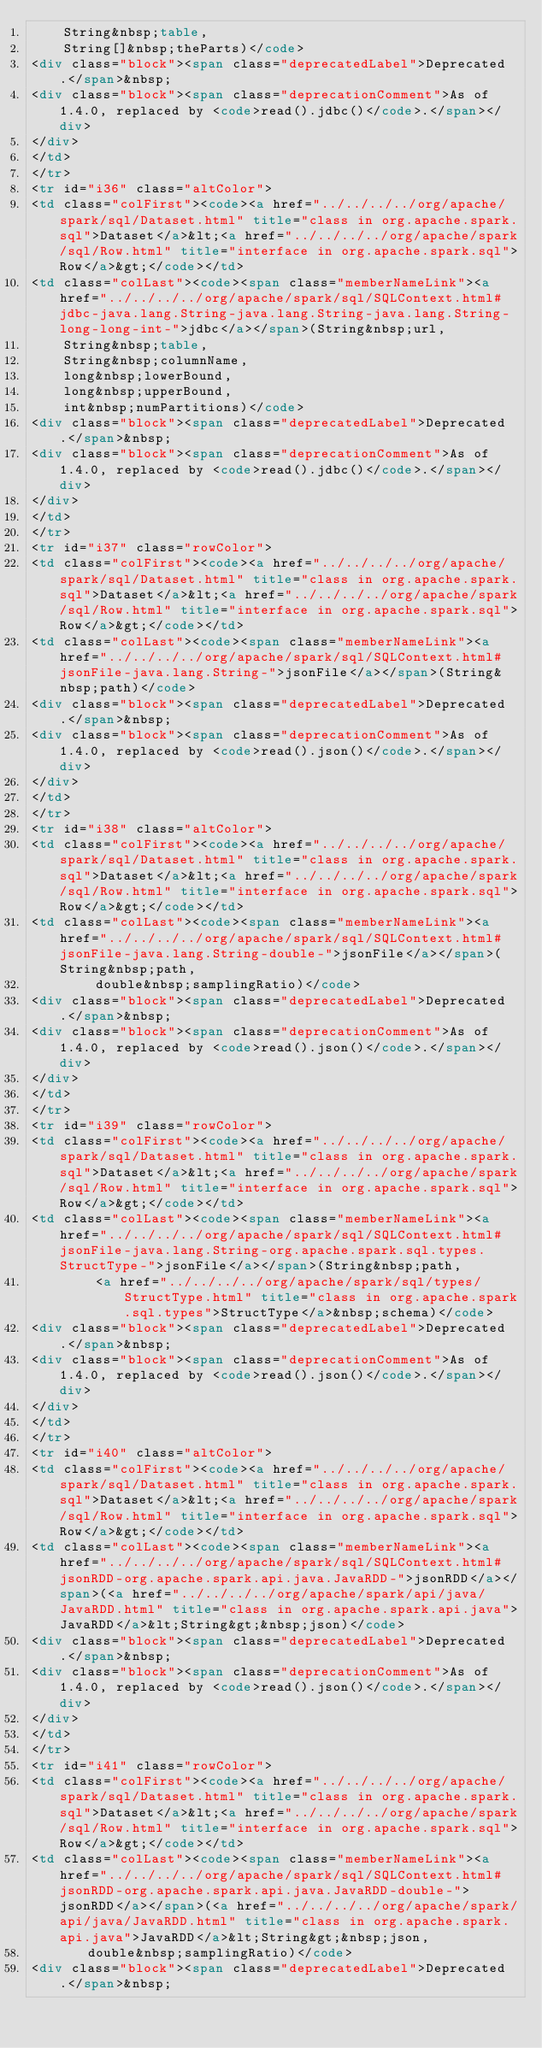<code> <loc_0><loc_0><loc_500><loc_500><_HTML_>    String&nbsp;table,
    String[]&nbsp;theParts)</code>
<div class="block"><span class="deprecatedLabel">Deprecated.</span>&nbsp;
<div class="block"><span class="deprecationComment">As of 1.4.0, replaced by <code>read().jdbc()</code>.</span></div>
</div>
</td>
</tr>
<tr id="i36" class="altColor">
<td class="colFirst"><code><a href="../../../../org/apache/spark/sql/Dataset.html" title="class in org.apache.spark.sql">Dataset</a>&lt;<a href="../../../../org/apache/spark/sql/Row.html" title="interface in org.apache.spark.sql">Row</a>&gt;</code></td>
<td class="colLast"><code><span class="memberNameLink"><a href="../../../../org/apache/spark/sql/SQLContext.html#jdbc-java.lang.String-java.lang.String-java.lang.String-long-long-int-">jdbc</a></span>(String&nbsp;url,
    String&nbsp;table,
    String&nbsp;columnName,
    long&nbsp;lowerBound,
    long&nbsp;upperBound,
    int&nbsp;numPartitions)</code>
<div class="block"><span class="deprecatedLabel">Deprecated.</span>&nbsp;
<div class="block"><span class="deprecationComment">As of 1.4.0, replaced by <code>read().jdbc()</code>.</span></div>
</div>
</td>
</tr>
<tr id="i37" class="rowColor">
<td class="colFirst"><code><a href="../../../../org/apache/spark/sql/Dataset.html" title="class in org.apache.spark.sql">Dataset</a>&lt;<a href="../../../../org/apache/spark/sql/Row.html" title="interface in org.apache.spark.sql">Row</a>&gt;</code></td>
<td class="colLast"><code><span class="memberNameLink"><a href="../../../../org/apache/spark/sql/SQLContext.html#jsonFile-java.lang.String-">jsonFile</a></span>(String&nbsp;path)</code>
<div class="block"><span class="deprecatedLabel">Deprecated.</span>&nbsp;
<div class="block"><span class="deprecationComment">As of 1.4.0, replaced by <code>read().json()</code>.</span></div>
</div>
</td>
</tr>
<tr id="i38" class="altColor">
<td class="colFirst"><code><a href="../../../../org/apache/spark/sql/Dataset.html" title="class in org.apache.spark.sql">Dataset</a>&lt;<a href="../../../../org/apache/spark/sql/Row.html" title="interface in org.apache.spark.sql">Row</a>&gt;</code></td>
<td class="colLast"><code><span class="memberNameLink"><a href="../../../../org/apache/spark/sql/SQLContext.html#jsonFile-java.lang.String-double-">jsonFile</a></span>(String&nbsp;path,
        double&nbsp;samplingRatio)</code>
<div class="block"><span class="deprecatedLabel">Deprecated.</span>&nbsp;
<div class="block"><span class="deprecationComment">As of 1.4.0, replaced by <code>read().json()</code>.</span></div>
</div>
</td>
</tr>
<tr id="i39" class="rowColor">
<td class="colFirst"><code><a href="../../../../org/apache/spark/sql/Dataset.html" title="class in org.apache.spark.sql">Dataset</a>&lt;<a href="../../../../org/apache/spark/sql/Row.html" title="interface in org.apache.spark.sql">Row</a>&gt;</code></td>
<td class="colLast"><code><span class="memberNameLink"><a href="../../../../org/apache/spark/sql/SQLContext.html#jsonFile-java.lang.String-org.apache.spark.sql.types.StructType-">jsonFile</a></span>(String&nbsp;path,
        <a href="../../../../org/apache/spark/sql/types/StructType.html" title="class in org.apache.spark.sql.types">StructType</a>&nbsp;schema)</code>
<div class="block"><span class="deprecatedLabel">Deprecated.</span>&nbsp;
<div class="block"><span class="deprecationComment">As of 1.4.0, replaced by <code>read().json()</code>.</span></div>
</div>
</td>
</tr>
<tr id="i40" class="altColor">
<td class="colFirst"><code><a href="../../../../org/apache/spark/sql/Dataset.html" title="class in org.apache.spark.sql">Dataset</a>&lt;<a href="../../../../org/apache/spark/sql/Row.html" title="interface in org.apache.spark.sql">Row</a>&gt;</code></td>
<td class="colLast"><code><span class="memberNameLink"><a href="../../../../org/apache/spark/sql/SQLContext.html#jsonRDD-org.apache.spark.api.java.JavaRDD-">jsonRDD</a></span>(<a href="../../../../org/apache/spark/api/java/JavaRDD.html" title="class in org.apache.spark.api.java">JavaRDD</a>&lt;String&gt;&nbsp;json)</code>
<div class="block"><span class="deprecatedLabel">Deprecated.</span>&nbsp;
<div class="block"><span class="deprecationComment">As of 1.4.0, replaced by <code>read().json()</code>.</span></div>
</div>
</td>
</tr>
<tr id="i41" class="rowColor">
<td class="colFirst"><code><a href="../../../../org/apache/spark/sql/Dataset.html" title="class in org.apache.spark.sql">Dataset</a>&lt;<a href="../../../../org/apache/spark/sql/Row.html" title="interface in org.apache.spark.sql">Row</a>&gt;</code></td>
<td class="colLast"><code><span class="memberNameLink"><a href="../../../../org/apache/spark/sql/SQLContext.html#jsonRDD-org.apache.spark.api.java.JavaRDD-double-">jsonRDD</a></span>(<a href="../../../../org/apache/spark/api/java/JavaRDD.html" title="class in org.apache.spark.api.java">JavaRDD</a>&lt;String&gt;&nbsp;json,
       double&nbsp;samplingRatio)</code>
<div class="block"><span class="deprecatedLabel">Deprecated.</span>&nbsp;</code> 